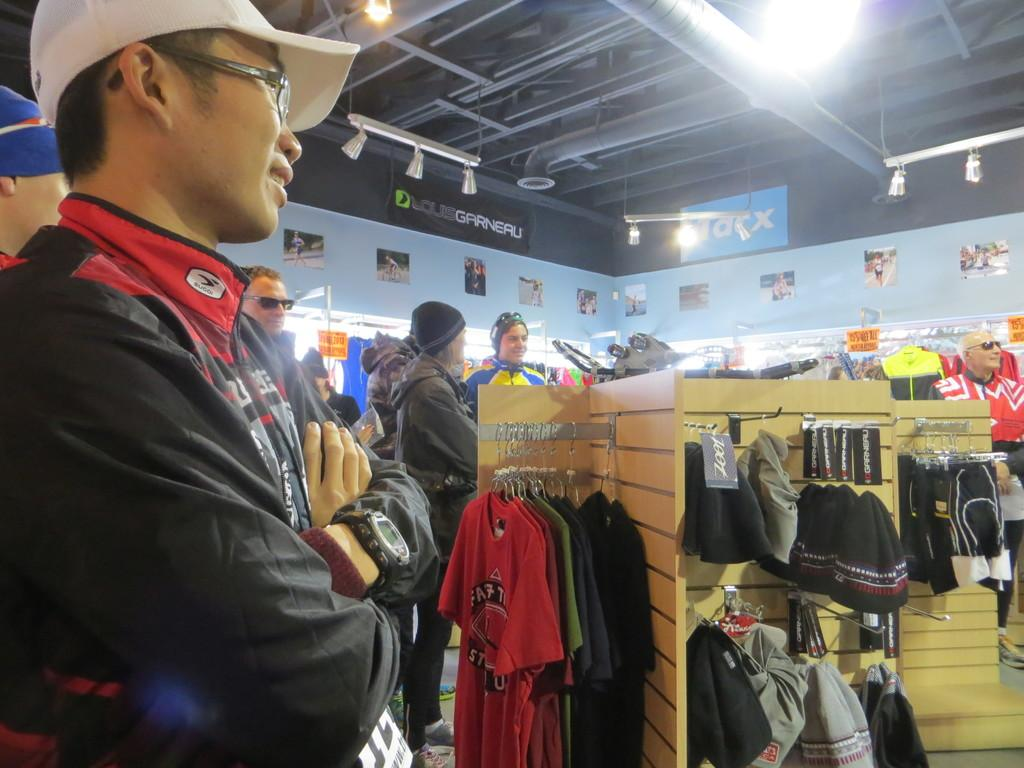Where was the image taken? The image was taken inside a shopping store. What are the people in the image doing? The people in the image are doing shopping. What type of items can be seen in the background of the image? Clothes and other accessories are visible in the background of the image. What type of health industry is depicted in the image? The image does not depict any health industry; it is taken inside a shopping store where people are shopping for clothes and accessories. 